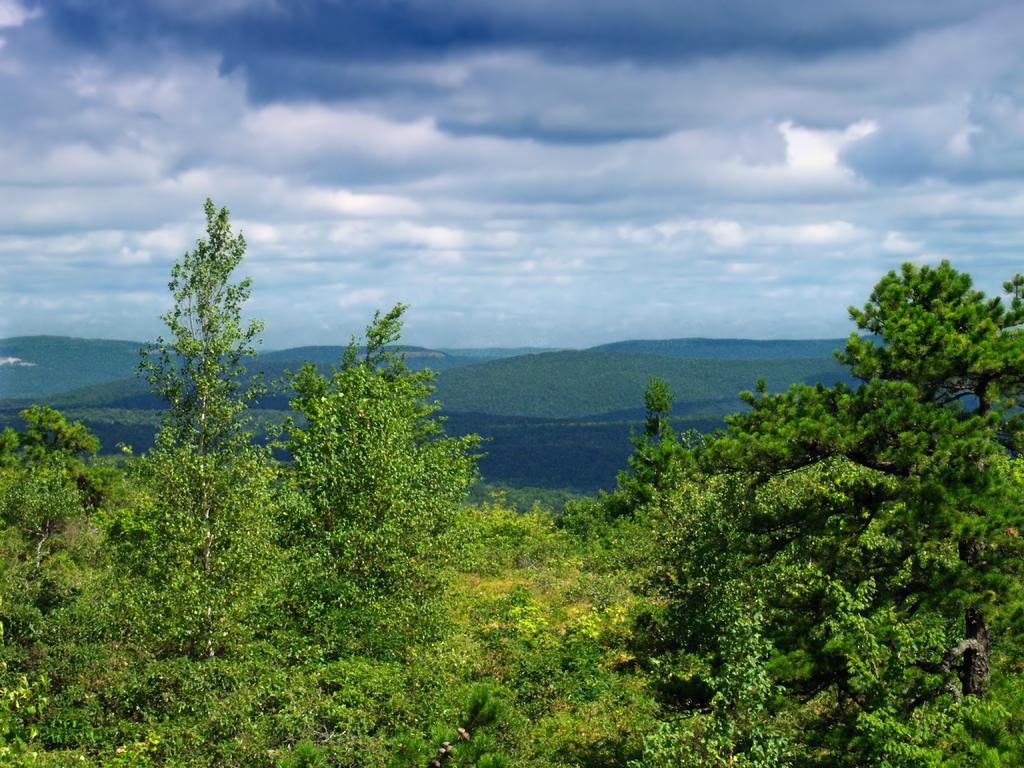Can you describe this image briefly? In the image there is a beautiful scenery with a lot of trees, plants and mountains. 